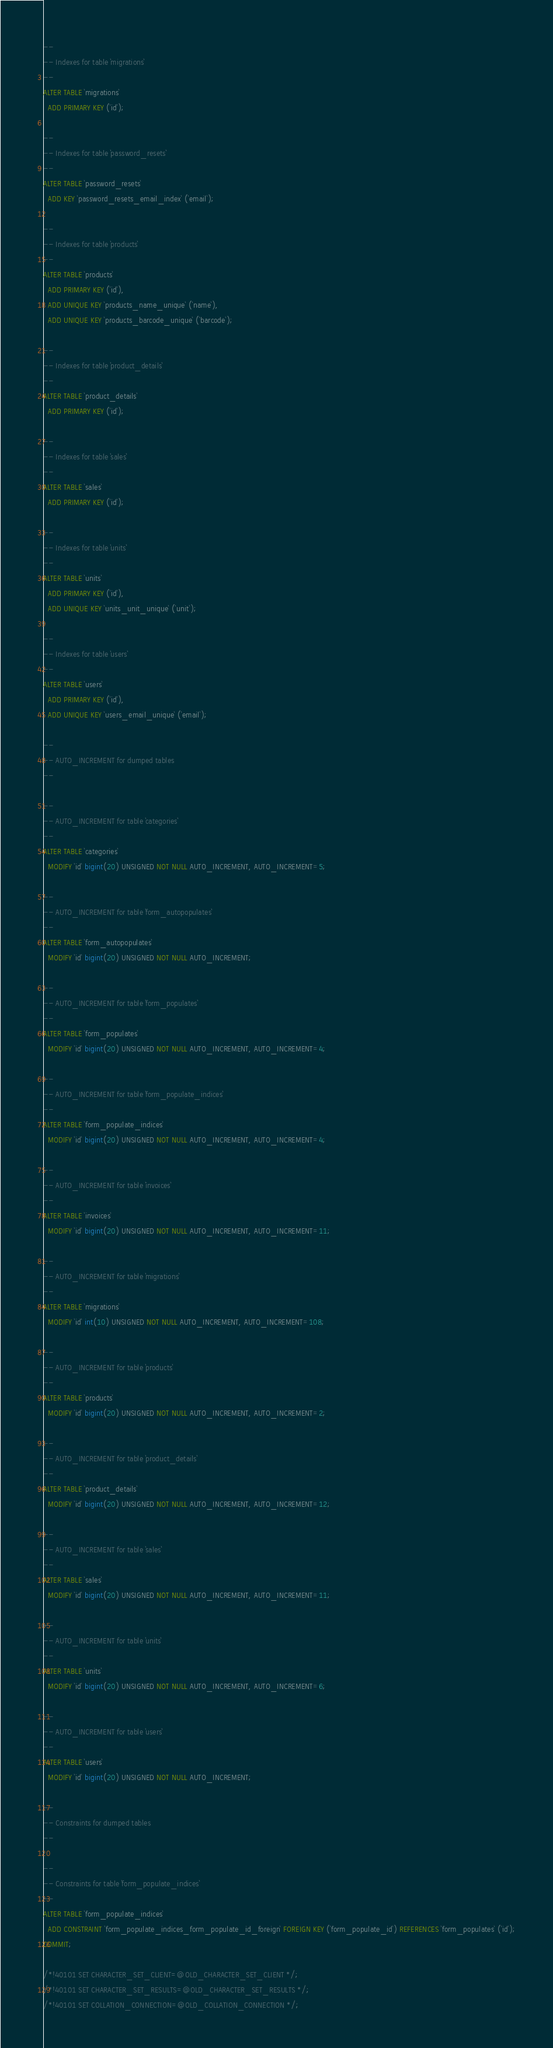Convert code to text. <code><loc_0><loc_0><loc_500><loc_500><_SQL_>--
-- Indexes for table `migrations`
--
ALTER TABLE `migrations`
  ADD PRIMARY KEY (`id`);

--
-- Indexes for table `password_resets`
--
ALTER TABLE `password_resets`
  ADD KEY `password_resets_email_index` (`email`);

--
-- Indexes for table `products`
--
ALTER TABLE `products`
  ADD PRIMARY KEY (`id`),
  ADD UNIQUE KEY `products_name_unique` (`name`),
  ADD UNIQUE KEY `products_barcode_unique` (`barcode`);

--
-- Indexes for table `product_details`
--
ALTER TABLE `product_details`
  ADD PRIMARY KEY (`id`);

--
-- Indexes for table `sales`
--
ALTER TABLE `sales`
  ADD PRIMARY KEY (`id`);

--
-- Indexes for table `units`
--
ALTER TABLE `units`
  ADD PRIMARY KEY (`id`),
  ADD UNIQUE KEY `units_unit_unique` (`unit`);

--
-- Indexes for table `users`
--
ALTER TABLE `users`
  ADD PRIMARY KEY (`id`),
  ADD UNIQUE KEY `users_email_unique` (`email`);

--
-- AUTO_INCREMENT for dumped tables
--

--
-- AUTO_INCREMENT for table `categories`
--
ALTER TABLE `categories`
  MODIFY `id` bigint(20) UNSIGNED NOT NULL AUTO_INCREMENT, AUTO_INCREMENT=5;

--
-- AUTO_INCREMENT for table `form_autopopulates`
--
ALTER TABLE `form_autopopulates`
  MODIFY `id` bigint(20) UNSIGNED NOT NULL AUTO_INCREMENT;

--
-- AUTO_INCREMENT for table `form_populates`
--
ALTER TABLE `form_populates`
  MODIFY `id` bigint(20) UNSIGNED NOT NULL AUTO_INCREMENT, AUTO_INCREMENT=4;

--
-- AUTO_INCREMENT for table `form_populate_indices`
--
ALTER TABLE `form_populate_indices`
  MODIFY `id` bigint(20) UNSIGNED NOT NULL AUTO_INCREMENT, AUTO_INCREMENT=4;

--
-- AUTO_INCREMENT for table `invoices`
--
ALTER TABLE `invoices`
  MODIFY `id` bigint(20) UNSIGNED NOT NULL AUTO_INCREMENT, AUTO_INCREMENT=11;

--
-- AUTO_INCREMENT for table `migrations`
--
ALTER TABLE `migrations`
  MODIFY `id` int(10) UNSIGNED NOT NULL AUTO_INCREMENT, AUTO_INCREMENT=108;

--
-- AUTO_INCREMENT for table `products`
--
ALTER TABLE `products`
  MODIFY `id` bigint(20) UNSIGNED NOT NULL AUTO_INCREMENT, AUTO_INCREMENT=2;

--
-- AUTO_INCREMENT for table `product_details`
--
ALTER TABLE `product_details`
  MODIFY `id` bigint(20) UNSIGNED NOT NULL AUTO_INCREMENT, AUTO_INCREMENT=12;

--
-- AUTO_INCREMENT for table `sales`
--
ALTER TABLE `sales`
  MODIFY `id` bigint(20) UNSIGNED NOT NULL AUTO_INCREMENT, AUTO_INCREMENT=11;

--
-- AUTO_INCREMENT for table `units`
--
ALTER TABLE `units`
  MODIFY `id` bigint(20) UNSIGNED NOT NULL AUTO_INCREMENT, AUTO_INCREMENT=6;

--
-- AUTO_INCREMENT for table `users`
--
ALTER TABLE `users`
  MODIFY `id` bigint(20) UNSIGNED NOT NULL AUTO_INCREMENT;

--
-- Constraints for dumped tables
--

--
-- Constraints for table `form_populate_indices`
--
ALTER TABLE `form_populate_indices`
  ADD CONSTRAINT `form_populate_indices_form_populate_id_foreign` FOREIGN KEY (`form_populate_id`) REFERENCES `form_populates` (`id`);
COMMIT;

/*!40101 SET CHARACTER_SET_CLIENT=@OLD_CHARACTER_SET_CLIENT */;
/*!40101 SET CHARACTER_SET_RESULTS=@OLD_CHARACTER_SET_RESULTS */;
/*!40101 SET COLLATION_CONNECTION=@OLD_COLLATION_CONNECTION */;
</code> 